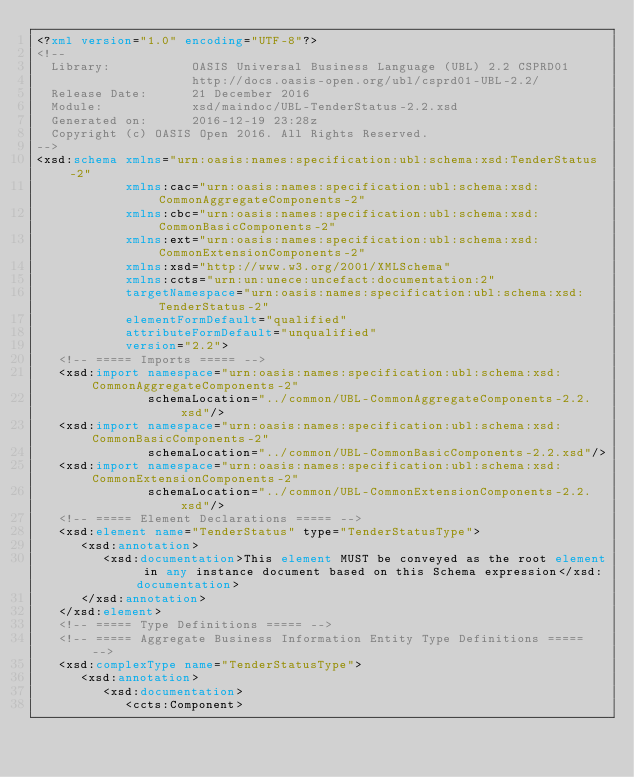<code> <loc_0><loc_0><loc_500><loc_500><_XML_><?xml version="1.0" encoding="UTF-8"?>
<!--
  Library:           OASIS Universal Business Language (UBL) 2.2 CSPRD01
                     http://docs.oasis-open.org/ubl/csprd01-UBL-2.2/
  Release Date:      21 December 2016
  Module:            xsd/maindoc/UBL-TenderStatus-2.2.xsd
  Generated on:      2016-12-19 23:28z
  Copyright (c) OASIS Open 2016. All Rights Reserved.
-->
<xsd:schema xmlns="urn:oasis:names:specification:ubl:schema:xsd:TenderStatus-2"
            xmlns:cac="urn:oasis:names:specification:ubl:schema:xsd:CommonAggregateComponents-2"
            xmlns:cbc="urn:oasis:names:specification:ubl:schema:xsd:CommonBasicComponents-2"
            xmlns:ext="urn:oasis:names:specification:ubl:schema:xsd:CommonExtensionComponents-2"
            xmlns:xsd="http://www.w3.org/2001/XMLSchema"
            xmlns:ccts="urn:un:unece:uncefact:documentation:2"
            targetNamespace="urn:oasis:names:specification:ubl:schema:xsd:TenderStatus-2"
            elementFormDefault="qualified"
            attributeFormDefault="unqualified"
            version="2.2">
   <!-- ===== Imports ===== -->
   <xsd:import namespace="urn:oasis:names:specification:ubl:schema:xsd:CommonAggregateComponents-2"
               schemaLocation="../common/UBL-CommonAggregateComponents-2.2.xsd"/>
   <xsd:import namespace="urn:oasis:names:specification:ubl:schema:xsd:CommonBasicComponents-2"
               schemaLocation="../common/UBL-CommonBasicComponents-2.2.xsd"/>
   <xsd:import namespace="urn:oasis:names:specification:ubl:schema:xsd:CommonExtensionComponents-2"
               schemaLocation="../common/UBL-CommonExtensionComponents-2.2.xsd"/>
   <!-- ===== Element Declarations ===== -->
   <xsd:element name="TenderStatus" type="TenderStatusType">
      <xsd:annotation>
         <xsd:documentation>This element MUST be conveyed as the root element in any instance document based on this Schema expression</xsd:documentation>
      </xsd:annotation>
   </xsd:element>
   <!-- ===== Type Definitions ===== -->
   <!-- ===== Aggregate Business Information Entity Type Definitions ===== -->
   <xsd:complexType name="TenderStatusType">
      <xsd:annotation>
         <xsd:documentation>
            <ccts:Component></code> 